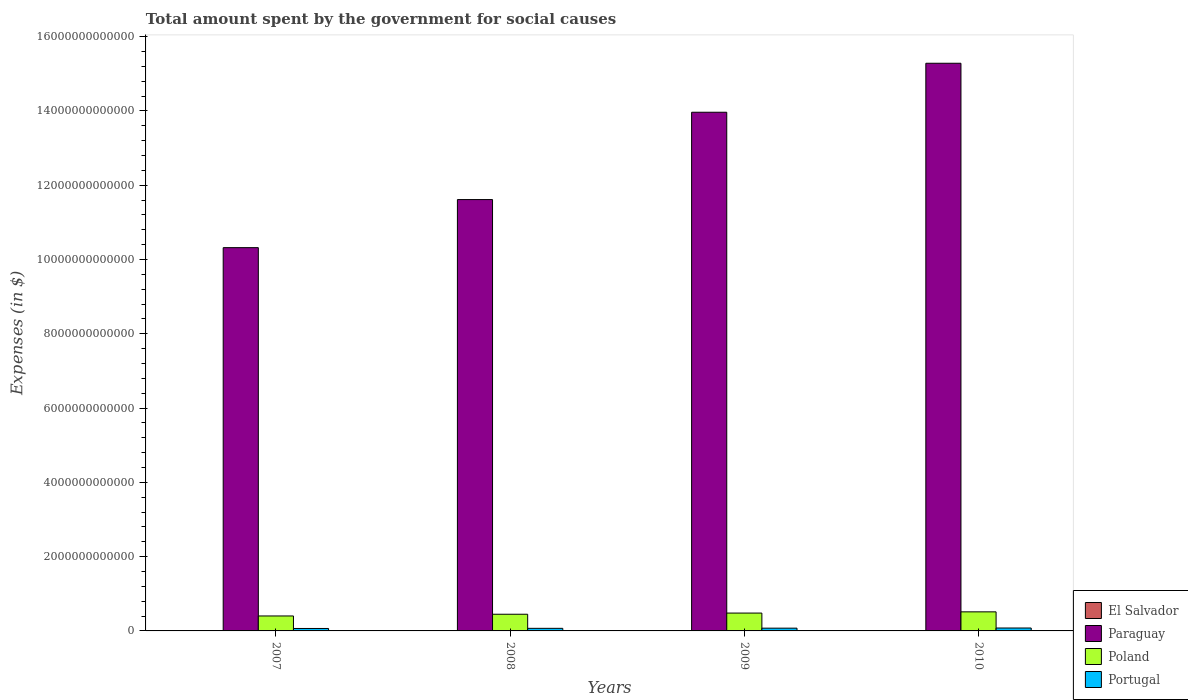How many different coloured bars are there?
Give a very brief answer. 4. Are the number of bars per tick equal to the number of legend labels?
Provide a succinct answer. Yes. How many bars are there on the 1st tick from the right?
Your answer should be very brief. 4. What is the amount spent for social causes by the government in Portugal in 2009?
Ensure brevity in your answer.  7.42e+1. Across all years, what is the maximum amount spent for social causes by the government in El Salvador?
Ensure brevity in your answer.  4.55e+09. Across all years, what is the minimum amount spent for social causes by the government in Poland?
Offer a terse response. 4.03e+11. In which year was the amount spent for social causes by the government in Portugal maximum?
Ensure brevity in your answer.  2010. What is the total amount spent for social causes by the government in El Salvador in the graph?
Your answer should be compact. 1.66e+1. What is the difference between the amount spent for social causes by the government in Portugal in 2007 and that in 2008?
Provide a short and direct response. -3.76e+09. What is the difference between the amount spent for social causes by the government in El Salvador in 2008 and the amount spent for social causes by the government in Poland in 2007?
Your answer should be compact. -3.99e+11. What is the average amount spent for social causes by the government in Poland per year?
Keep it short and to the point. 4.62e+11. In the year 2010, what is the difference between the amount spent for social causes by the government in El Salvador and amount spent for social causes by the government in Poland?
Your answer should be compact. -5.09e+11. What is the ratio of the amount spent for social causes by the government in Poland in 2008 to that in 2010?
Keep it short and to the point. 0.88. What is the difference between the highest and the second highest amount spent for social causes by the government in El Salvador?
Provide a succinct answer. 9.62e+07. What is the difference between the highest and the lowest amount spent for social causes by the government in El Salvador?
Give a very brief answer. 1.06e+09. What does the 1st bar from the left in 2009 represents?
Provide a succinct answer. El Salvador. How many bars are there?
Ensure brevity in your answer.  16. What is the difference between two consecutive major ticks on the Y-axis?
Ensure brevity in your answer.  2.00e+12. Are the values on the major ticks of Y-axis written in scientific E-notation?
Offer a very short reply. No. Does the graph contain grids?
Make the answer very short. No. How many legend labels are there?
Offer a very short reply. 4. How are the legend labels stacked?
Your response must be concise. Vertical. What is the title of the graph?
Your response must be concise. Total amount spent by the government for social causes. Does "Nicaragua" appear as one of the legend labels in the graph?
Provide a short and direct response. No. What is the label or title of the Y-axis?
Give a very brief answer. Expenses (in $). What is the Expenses (in $) in El Salvador in 2007?
Provide a succinct answer. 3.49e+09. What is the Expenses (in $) of Paraguay in 2007?
Give a very brief answer. 1.03e+13. What is the Expenses (in $) in Poland in 2007?
Your answer should be very brief. 4.03e+11. What is the Expenses (in $) of Portugal in 2007?
Ensure brevity in your answer.  6.59e+1. What is the Expenses (in $) of El Salvador in 2008?
Make the answer very short. 4.09e+09. What is the Expenses (in $) in Paraguay in 2008?
Give a very brief answer. 1.16e+13. What is the Expenses (in $) of Poland in 2008?
Make the answer very short. 4.49e+11. What is the Expenses (in $) in Portugal in 2008?
Provide a short and direct response. 6.96e+1. What is the Expenses (in $) in El Salvador in 2009?
Give a very brief answer. 4.55e+09. What is the Expenses (in $) in Paraguay in 2009?
Provide a succinct answer. 1.40e+13. What is the Expenses (in $) of Poland in 2009?
Your answer should be very brief. 4.81e+11. What is the Expenses (in $) of Portugal in 2009?
Your answer should be compact. 7.42e+1. What is the Expenses (in $) of El Salvador in 2010?
Your response must be concise. 4.45e+09. What is the Expenses (in $) in Paraguay in 2010?
Give a very brief answer. 1.53e+13. What is the Expenses (in $) of Poland in 2010?
Keep it short and to the point. 5.13e+11. What is the Expenses (in $) in Portugal in 2010?
Provide a short and direct response. 7.84e+1. Across all years, what is the maximum Expenses (in $) in El Salvador?
Your answer should be compact. 4.55e+09. Across all years, what is the maximum Expenses (in $) of Paraguay?
Ensure brevity in your answer.  1.53e+13. Across all years, what is the maximum Expenses (in $) in Poland?
Provide a short and direct response. 5.13e+11. Across all years, what is the maximum Expenses (in $) of Portugal?
Offer a very short reply. 7.84e+1. Across all years, what is the minimum Expenses (in $) in El Salvador?
Offer a very short reply. 3.49e+09. Across all years, what is the minimum Expenses (in $) in Paraguay?
Provide a short and direct response. 1.03e+13. Across all years, what is the minimum Expenses (in $) of Poland?
Offer a very short reply. 4.03e+11. Across all years, what is the minimum Expenses (in $) in Portugal?
Your answer should be very brief. 6.59e+1. What is the total Expenses (in $) of El Salvador in the graph?
Ensure brevity in your answer.  1.66e+1. What is the total Expenses (in $) in Paraguay in the graph?
Your answer should be very brief. 5.12e+13. What is the total Expenses (in $) of Poland in the graph?
Ensure brevity in your answer.  1.85e+12. What is the total Expenses (in $) of Portugal in the graph?
Provide a succinct answer. 2.88e+11. What is the difference between the Expenses (in $) of El Salvador in 2007 and that in 2008?
Provide a succinct answer. -5.98e+08. What is the difference between the Expenses (in $) in Paraguay in 2007 and that in 2008?
Keep it short and to the point. -1.29e+12. What is the difference between the Expenses (in $) of Poland in 2007 and that in 2008?
Provide a succinct answer. -4.65e+1. What is the difference between the Expenses (in $) in Portugal in 2007 and that in 2008?
Keep it short and to the point. -3.76e+09. What is the difference between the Expenses (in $) of El Salvador in 2007 and that in 2009?
Give a very brief answer. -1.06e+09. What is the difference between the Expenses (in $) in Paraguay in 2007 and that in 2009?
Give a very brief answer. -3.65e+12. What is the difference between the Expenses (in $) of Poland in 2007 and that in 2009?
Offer a very short reply. -7.78e+1. What is the difference between the Expenses (in $) in Portugal in 2007 and that in 2009?
Offer a very short reply. -8.35e+09. What is the difference between the Expenses (in $) of El Salvador in 2007 and that in 2010?
Keep it short and to the point. -9.60e+08. What is the difference between the Expenses (in $) of Paraguay in 2007 and that in 2010?
Keep it short and to the point. -4.96e+12. What is the difference between the Expenses (in $) in Poland in 2007 and that in 2010?
Your response must be concise. -1.11e+11. What is the difference between the Expenses (in $) in Portugal in 2007 and that in 2010?
Keep it short and to the point. -1.25e+1. What is the difference between the Expenses (in $) of El Salvador in 2008 and that in 2009?
Offer a very short reply. -4.58e+08. What is the difference between the Expenses (in $) in Paraguay in 2008 and that in 2009?
Your response must be concise. -2.35e+12. What is the difference between the Expenses (in $) in Poland in 2008 and that in 2009?
Give a very brief answer. -3.14e+1. What is the difference between the Expenses (in $) in Portugal in 2008 and that in 2009?
Offer a terse response. -4.59e+09. What is the difference between the Expenses (in $) of El Salvador in 2008 and that in 2010?
Provide a succinct answer. -3.62e+08. What is the difference between the Expenses (in $) in Paraguay in 2008 and that in 2010?
Provide a short and direct response. -3.67e+12. What is the difference between the Expenses (in $) of Poland in 2008 and that in 2010?
Keep it short and to the point. -6.41e+1. What is the difference between the Expenses (in $) of Portugal in 2008 and that in 2010?
Give a very brief answer. -8.71e+09. What is the difference between the Expenses (in $) of El Salvador in 2009 and that in 2010?
Your answer should be compact. 9.62e+07. What is the difference between the Expenses (in $) in Paraguay in 2009 and that in 2010?
Make the answer very short. -1.32e+12. What is the difference between the Expenses (in $) of Poland in 2009 and that in 2010?
Provide a succinct answer. -3.28e+1. What is the difference between the Expenses (in $) of Portugal in 2009 and that in 2010?
Your response must be concise. -4.12e+09. What is the difference between the Expenses (in $) in El Salvador in 2007 and the Expenses (in $) in Paraguay in 2008?
Offer a very short reply. -1.16e+13. What is the difference between the Expenses (in $) of El Salvador in 2007 and the Expenses (in $) of Poland in 2008?
Keep it short and to the point. -4.46e+11. What is the difference between the Expenses (in $) in El Salvador in 2007 and the Expenses (in $) in Portugal in 2008?
Your answer should be compact. -6.61e+1. What is the difference between the Expenses (in $) in Paraguay in 2007 and the Expenses (in $) in Poland in 2008?
Ensure brevity in your answer.  9.87e+12. What is the difference between the Expenses (in $) of Paraguay in 2007 and the Expenses (in $) of Portugal in 2008?
Offer a terse response. 1.02e+13. What is the difference between the Expenses (in $) in Poland in 2007 and the Expenses (in $) in Portugal in 2008?
Ensure brevity in your answer.  3.33e+11. What is the difference between the Expenses (in $) in El Salvador in 2007 and the Expenses (in $) in Paraguay in 2009?
Provide a short and direct response. -1.40e+13. What is the difference between the Expenses (in $) in El Salvador in 2007 and the Expenses (in $) in Poland in 2009?
Ensure brevity in your answer.  -4.77e+11. What is the difference between the Expenses (in $) in El Salvador in 2007 and the Expenses (in $) in Portugal in 2009?
Keep it short and to the point. -7.07e+1. What is the difference between the Expenses (in $) of Paraguay in 2007 and the Expenses (in $) of Poland in 2009?
Offer a terse response. 9.84e+12. What is the difference between the Expenses (in $) of Paraguay in 2007 and the Expenses (in $) of Portugal in 2009?
Keep it short and to the point. 1.02e+13. What is the difference between the Expenses (in $) of Poland in 2007 and the Expenses (in $) of Portugal in 2009?
Offer a terse response. 3.29e+11. What is the difference between the Expenses (in $) of El Salvador in 2007 and the Expenses (in $) of Paraguay in 2010?
Your answer should be compact. -1.53e+13. What is the difference between the Expenses (in $) in El Salvador in 2007 and the Expenses (in $) in Poland in 2010?
Ensure brevity in your answer.  -5.10e+11. What is the difference between the Expenses (in $) in El Salvador in 2007 and the Expenses (in $) in Portugal in 2010?
Your response must be concise. -7.49e+1. What is the difference between the Expenses (in $) of Paraguay in 2007 and the Expenses (in $) of Poland in 2010?
Your response must be concise. 9.81e+12. What is the difference between the Expenses (in $) of Paraguay in 2007 and the Expenses (in $) of Portugal in 2010?
Provide a succinct answer. 1.02e+13. What is the difference between the Expenses (in $) of Poland in 2007 and the Expenses (in $) of Portugal in 2010?
Your response must be concise. 3.24e+11. What is the difference between the Expenses (in $) in El Salvador in 2008 and the Expenses (in $) in Paraguay in 2009?
Your answer should be very brief. -1.40e+13. What is the difference between the Expenses (in $) of El Salvador in 2008 and the Expenses (in $) of Poland in 2009?
Offer a terse response. -4.77e+11. What is the difference between the Expenses (in $) in El Salvador in 2008 and the Expenses (in $) in Portugal in 2009?
Your answer should be compact. -7.01e+1. What is the difference between the Expenses (in $) in Paraguay in 2008 and the Expenses (in $) in Poland in 2009?
Ensure brevity in your answer.  1.11e+13. What is the difference between the Expenses (in $) in Paraguay in 2008 and the Expenses (in $) in Portugal in 2009?
Your answer should be very brief. 1.15e+13. What is the difference between the Expenses (in $) in Poland in 2008 and the Expenses (in $) in Portugal in 2009?
Give a very brief answer. 3.75e+11. What is the difference between the Expenses (in $) in El Salvador in 2008 and the Expenses (in $) in Paraguay in 2010?
Ensure brevity in your answer.  -1.53e+13. What is the difference between the Expenses (in $) in El Salvador in 2008 and the Expenses (in $) in Poland in 2010?
Ensure brevity in your answer.  -5.09e+11. What is the difference between the Expenses (in $) of El Salvador in 2008 and the Expenses (in $) of Portugal in 2010?
Your answer should be very brief. -7.43e+1. What is the difference between the Expenses (in $) in Paraguay in 2008 and the Expenses (in $) in Poland in 2010?
Give a very brief answer. 1.11e+13. What is the difference between the Expenses (in $) of Paraguay in 2008 and the Expenses (in $) of Portugal in 2010?
Provide a short and direct response. 1.15e+13. What is the difference between the Expenses (in $) of Poland in 2008 and the Expenses (in $) of Portugal in 2010?
Give a very brief answer. 3.71e+11. What is the difference between the Expenses (in $) of El Salvador in 2009 and the Expenses (in $) of Paraguay in 2010?
Offer a terse response. -1.53e+13. What is the difference between the Expenses (in $) of El Salvador in 2009 and the Expenses (in $) of Poland in 2010?
Provide a short and direct response. -5.09e+11. What is the difference between the Expenses (in $) of El Salvador in 2009 and the Expenses (in $) of Portugal in 2010?
Give a very brief answer. -7.38e+1. What is the difference between the Expenses (in $) of Paraguay in 2009 and the Expenses (in $) of Poland in 2010?
Your answer should be very brief. 1.35e+13. What is the difference between the Expenses (in $) of Paraguay in 2009 and the Expenses (in $) of Portugal in 2010?
Make the answer very short. 1.39e+13. What is the difference between the Expenses (in $) of Poland in 2009 and the Expenses (in $) of Portugal in 2010?
Give a very brief answer. 4.02e+11. What is the average Expenses (in $) in El Salvador per year?
Keep it short and to the point. 4.15e+09. What is the average Expenses (in $) of Paraguay per year?
Offer a very short reply. 1.28e+13. What is the average Expenses (in $) in Poland per year?
Your response must be concise. 4.62e+11. What is the average Expenses (in $) in Portugal per year?
Keep it short and to the point. 7.20e+1. In the year 2007, what is the difference between the Expenses (in $) of El Salvador and Expenses (in $) of Paraguay?
Provide a succinct answer. -1.03e+13. In the year 2007, what is the difference between the Expenses (in $) in El Salvador and Expenses (in $) in Poland?
Keep it short and to the point. -3.99e+11. In the year 2007, what is the difference between the Expenses (in $) in El Salvador and Expenses (in $) in Portugal?
Provide a short and direct response. -6.24e+1. In the year 2007, what is the difference between the Expenses (in $) in Paraguay and Expenses (in $) in Poland?
Your answer should be very brief. 9.92e+12. In the year 2007, what is the difference between the Expenses (in $) of Paraguay and Expenses (in $) of Portugal?
Your answer should be very brief. 1.03e+13. In the year 2007, what is the difference between the Expenses (in $) of Poland and Expenses (in $) of Portugal?
Offer a terse response. 3.37e+11. In the year 2008, what is the difference between the Expenses (in $) of El Salvador and Expenses (in $) of Paraguay?
Provide a succinct answer. -1.16e+13. In the year 2008, what is the difference between the Expenses (in $) of El Salvador and Expenses (in $) of Poland?
Offer a very short reply. -4.45e+11. In the year 2008, what is the difference between the Expenses (in $) of El Salvador and Expenses (in $) of Portugal?
Provide a short and direct response. -6.56e+1. In the year 2008, what is the difference between the Expenses (in $) of Paraguay and Expenses (in $) of Poland?
Provide a short and direct response. 1.12e+13. In the year 2008, what is the difference between the Expenses (in $) of Paraguay and Expenses (in $) of Portugal?
Ensure brevity in your answer.  1.15e+13. In the year 2008, what is the difference between the Expenses (in $) of Poland and Expenses (in $) of Portugal?
Offer a very short reply. 3.80e+11. In the year 2009, what is the difference between the Expenses (in $) in El Salvador and Expenses (in $) in Paraguay?
Offer a terse response. -1.40e+13. In the year 2009, what is the difference between the Expenses (in $) of El Salvador and Expenses (in $) of Poland?
Make the answer very short. -4.76e+11. In the year 2009, what is the difference between the Expenses (in $) in El Salvador and Expenses (in $) in Portugal?
Give a very brief answer. -6.97e+1. In the year 2009, what is the difference between the Expenses (in $) in Paraguay and Expenses (in $) in Poland?
Provide a succinct answer. 1.35e+13. In the year 2009, what is the difference between the Expenses (in $) in Paraguay and Expenses (in $) in Portugal?
Provide a short and direct response. 1.39e+13. In the year 2009, what is the difference between the Expenses (in $) in Poland and Expenses (in $) in Portugal?
Offer a terse response. 4.06e+11. In the year 2010, what is the difference between the Expenses (in $) of El Salvador and Expenses (in $) of Paraguay?
Provide a short and direct response. -1.53e+13. In the year 2010, what is the difference between the Expenses (in $) of El Salvador and Expenses (in $) of Poland?
Provide a succinct answer. -5.09e+11. In the year 2010, what is the difference between the Expenses (in $) of El Salvador and Expenses (in $) of Portugal?
Give a very brief answer. -7.39e+1. In the year 2010, what is the difference between the Expenses (in $) in Paraguay and Expenses (in $) in Poland?
Your answer should be very brief. 1.48e+13. In the year 2010, what is the difference between the Expenses (in $) in Paraguay and Expenses (in $) in Portugal?
Provide a short and direct response. 1.52e+13. In the year 2010, what is the difference between the Expenses (in $) of Poland and Expenses (in $) of Portugal?
Keep it short and to the point. 4.35e+11. What is the ratio of the Expenses (in $) of El Salvador in 2007 to that in 2008?
Your response must be concise. 0.85. What is the ratio of the Expenses (in $) of Paraguay in 2007 to that in 2008?
Offer a terse response. 0.89. What is the ratio of the Expenses (in $) of Poland in 2007 to that in 2008?
Make the answer very short. 0.9. What is the ratio of the Expenses (in $) in Portugal in 2007 to that in 2008?
Make the answer very short. 0.95. What is the ratio of the Expenses (in $) in El Salvador in 2007 to that in 2009?
Make the answer very short. 0.77. What is the ratio of the Expenses (in $) in Paraguay in 2007 to that in 2009?
Keep it short and to the point. 0.74. What is the ratio of the Expenses (in $) of Poland in 2007 to that in 2009?
Ensure brevity in your answer.  0.84. What is the ratio of the Expenses (in $) of Portugal in 2007 to that in 2009?
Keep it short and to the point. 0.89. What is the ratio of the Expenses (in $) in El Salvador in 2007 to that in 2010?
Offer a very short reply. 0.78. What is the ratio of the Expenses (in $) in Paraguay in 2007 to that in 2010?
Keep it short and to the point. 0.68. What is the ratio of the Expenses (in $) of Poland in 2007 to that in 2010?
Provide a succinct answer. 0.78. What is the ratio of the Expenses (in $) of Portugal in 2007 to that in 2010?
Give a very brief answer. 0.84. What is the ratio of the Expenses (in $) of El Salvador in 2008 to that in 2009?
Offer a very short reply. 0.9. What is the ratio of the Expenses (in $) in Paraguay in 2008 to that in 2009?
Your answer should be very brief. 0.83. What is the ratio of the Expenses (in $) of Poland in 2008 to that in 2009?
Offer a terse response. 0.93. What is the ratio of the Expenses (in $) of Portugal in 2008 to that in 2009?
Ensure brevity in your answer.  0.94. What is the ratio of the Expenses (in $) in El Salvador in 2008 to that in 2010?
Make the answer very short. 0.92. What is the ratio of the Expenses (in $) in Paraguay in 2008 to that in 2010?
Give a very brief answer. 0.76. What is the ratio of the Expenses (in $) of Poland in 2008 to that in 2010?
Give a very brief answer. 0.88. What is the ratio of the Expenses (in $) of Portugal in 2008 to that in 2010?
Offer a very short reply. 0.89. What is the ratio of the Expenses (in $) in El Salvador in 2009 to that in 2010?
Keep it short and to the point. 1.02. What is the ratio of the Expenses (in $) in Paraguay in 2009 to that in 2010?
Offer a terse response. 0.91. What is the ratio of the Expenses (in $) of Poland in 2009 to that in 2010?
Give a very brief answer. 0.94. What is the ratio of the Expenses (in $) of Portugal in 2009 to that in 2010?
Offer a very short reply. 0.95. What is the difference between the highest and the second highest Expenses (in $) in El Salvador?
Your answer should be very brief. 9.62e+07. What is the difference between the highest and the second highest Expenses (in $) in Paraguay?
Ensure brevity in your answer.  1.32e+12. What is the difference between the highest and the second highest Expenses (in $) in Poland?
Give a very brief answer. 3.28e+1. What is the difference between the highest and the second highest Expenses (in $) of Portugal?
Make the answer very short. 4.12e+09. What is the difference between the highest and the lowest Expenses (in $) in El Salvador?
Your answer should be compact. 1.06e+09. What is the difference between the highest and the lowest Expenses (in $) in Paraguay?
Your response must be concise. 4.96e+12. What is the difference between the highest and the lowest Expenses (in $) in Poland?
Provide a succinct answer. 1.11e+11. What is the difference between the highest and the lowest Expenses (in $) in Portugal?
Give a very brief answer. 1.25e+1. 